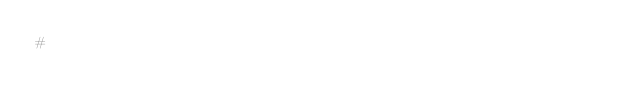<code> <loc_0><loc_0><loc_500><loc_500><_Python_>#</code> 